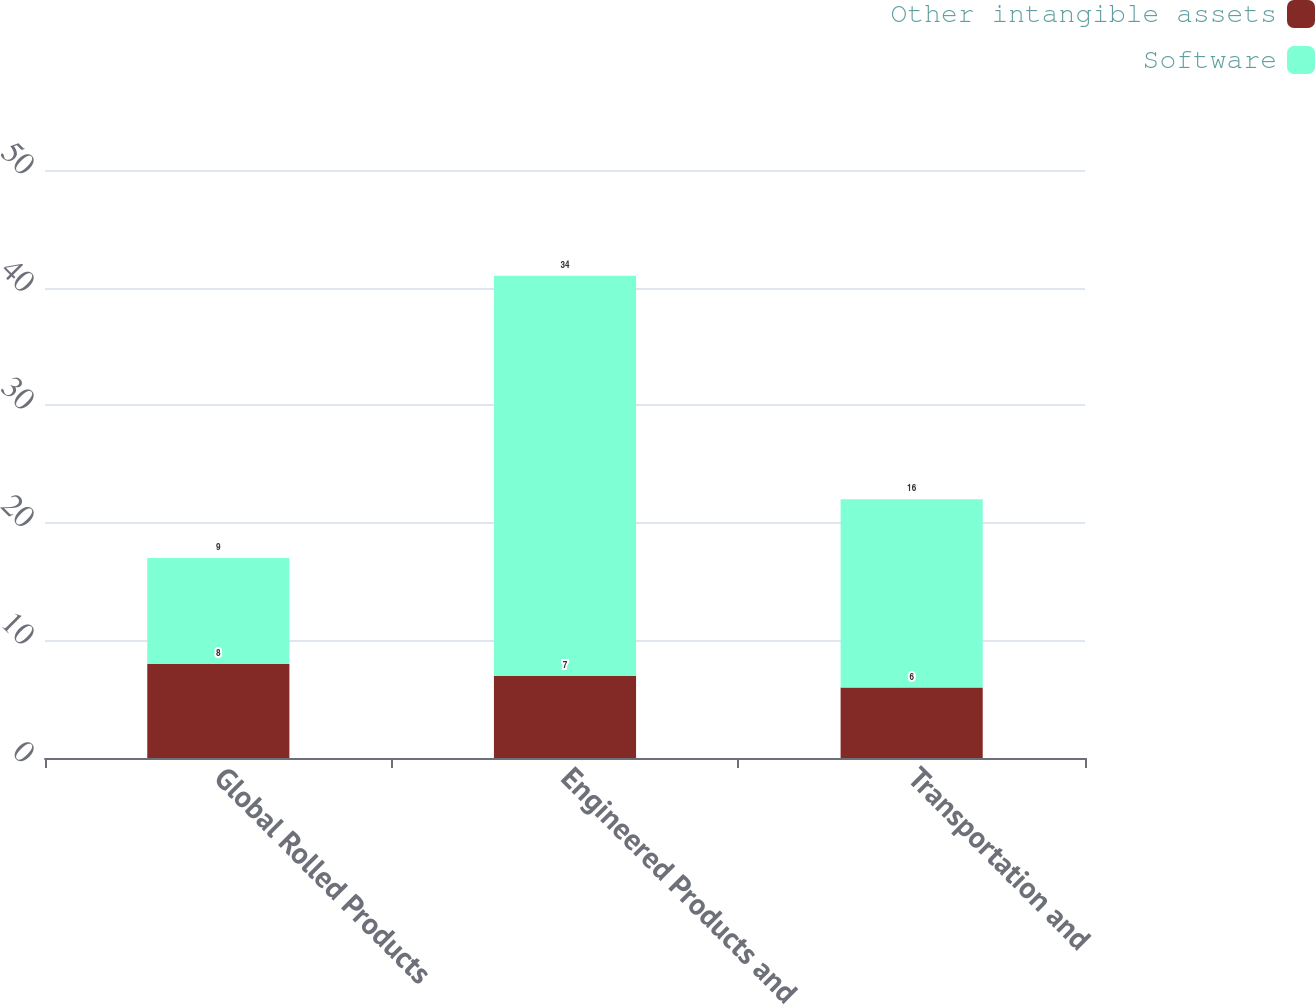<chart> <loc_0><loc_0><loc_500><loc_500><stacked_bar_chart><ecel><fcel>Global Rolled Products<fcel>Engineered Products and<fcel>Transportation and<nl><fcel>Other intangible assets<fcel>8<fcel>7<fcel>6<nl><fcel>Software<fcel>9<fcel>34<fcel>16<nl></chart> 